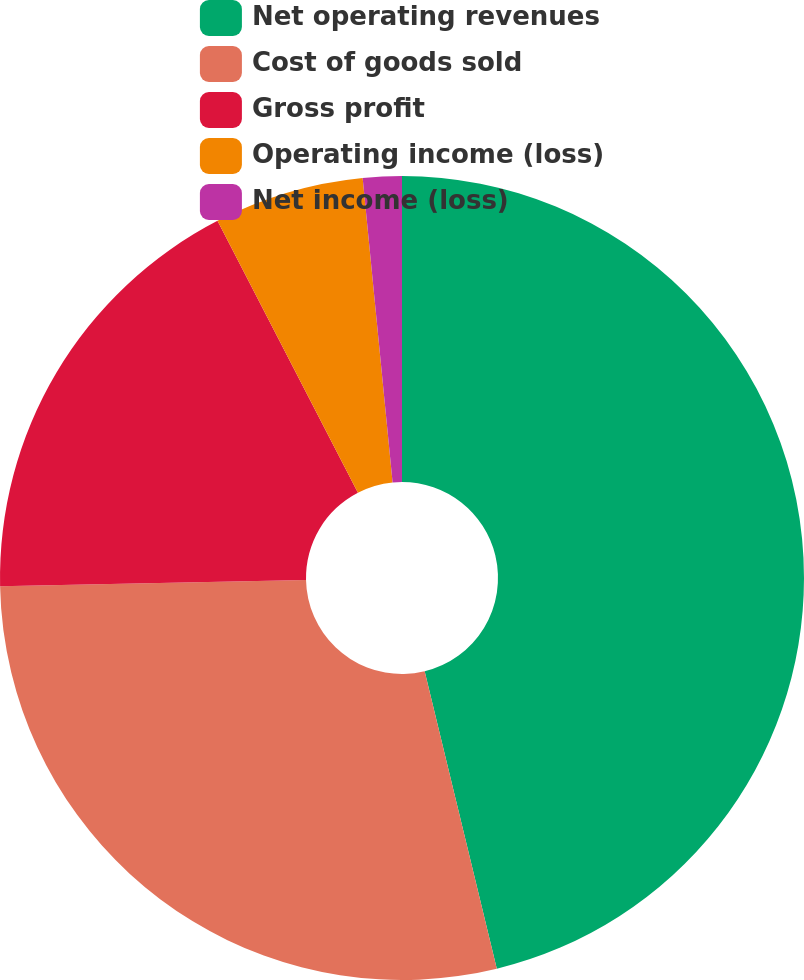Convert chart. <chart><loc_0><loc_0><loc_500><loc_500><pie_chart><fcel>Net operating revenues<fcel>Cost of goods sold<fcel>Gross profit<fcel>Operating income (loss)<fcel>Net income (loss)<nl><fcel>46.21%<fcel>28.46%<fcel>17.74%<fcel>6.03%<fcel>1.56%<nl></chart> 